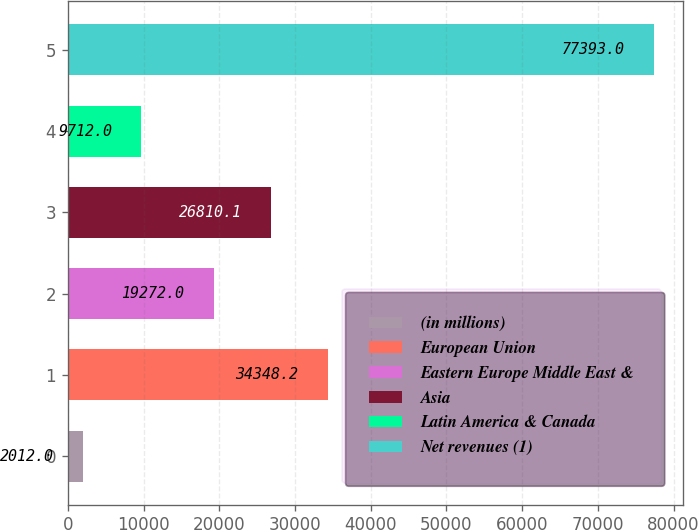<chart> <loc_0><loc_0><loc_500><loc_500><bar_chart><fcel>(in millions)<fcel>European Union<fcel>Eastern Europe Middle East &<fcel>Asia<fcel>Latin America & Canada<fcel>Net revenues (1)<nl><fcel>2012<fcel>34348.2<fcel>19272<fcel>26810.1<fcel>9712<fcel>77393<nl></chart> 